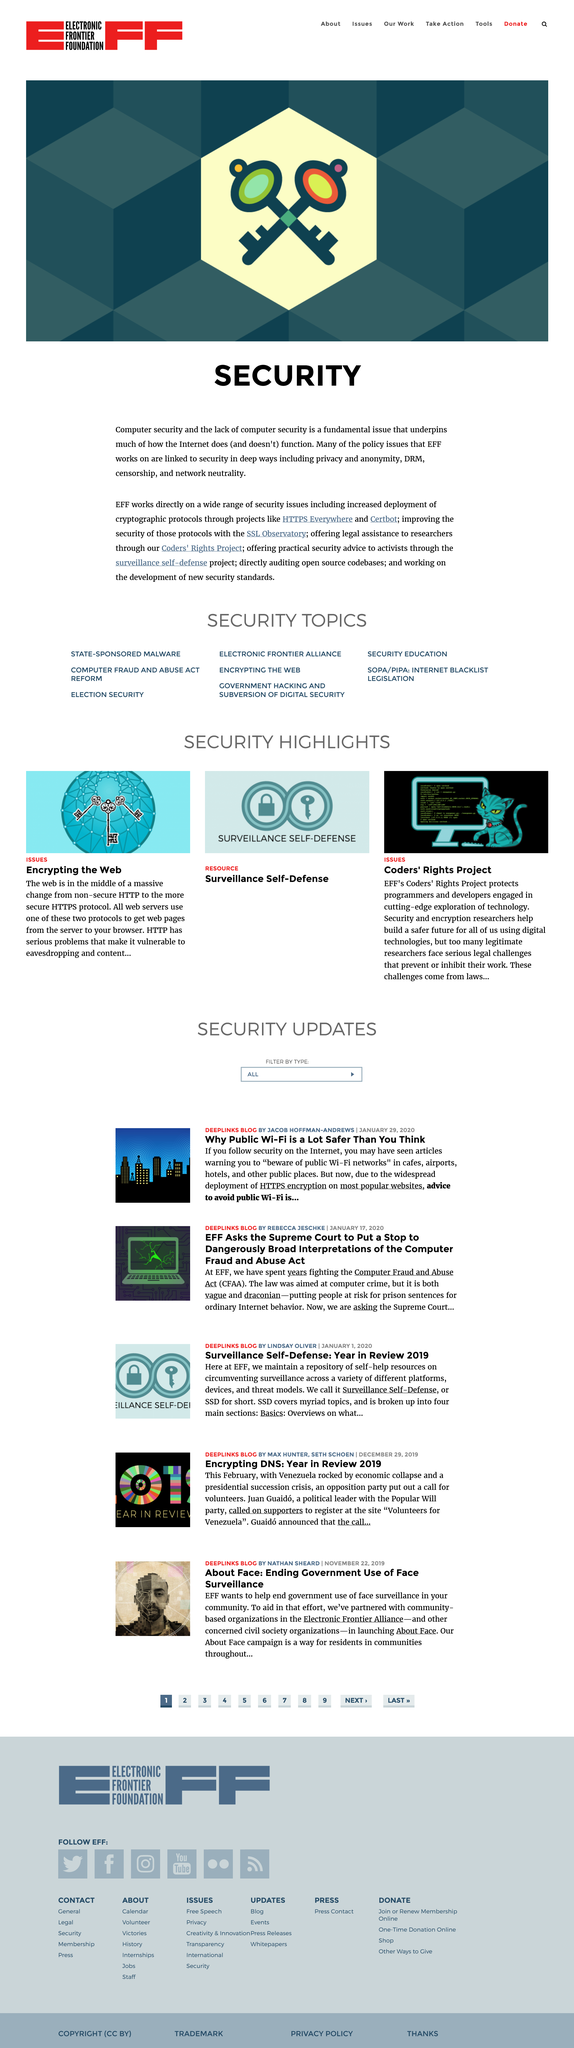Mention a couple of crucial points in this snapshot. The EFF is actively involved in various projects, such as HTTPS Everywhere, Cerbot, SSL Observatory, Coders' Rights Project, and Surveillance Self-Defense, which aim to promote online privacy and security. The Electronic Frontier Foundation works directly on a wide range of security issues. The lack of computer security is a fundamental issue that underpins much of how the internet works. 